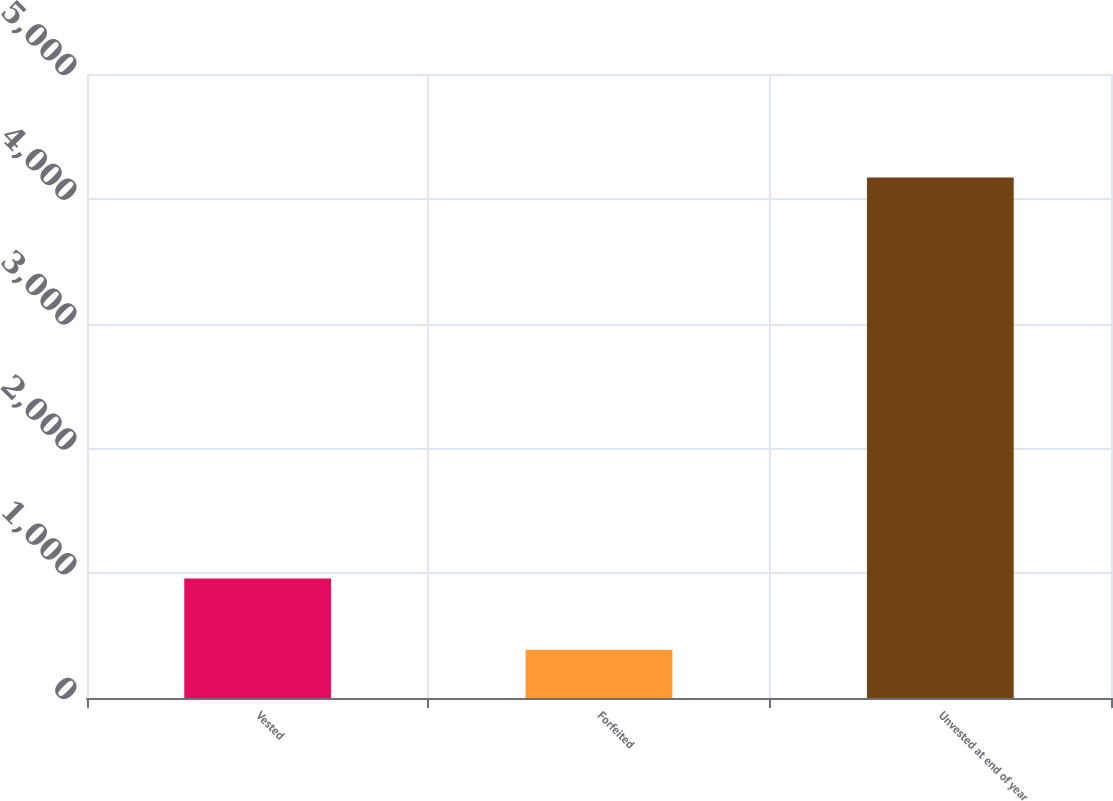Convert chart to OTSL. <chart><loc_0><loc_0><loc_500><loc_500><bar_chart><fcel>Vested<fcel>Forfeited<fcel>Unvested at end of year<nl><fcel>958<fcel>386<fcel>4171<nl></chart> 